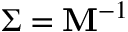<formula> <loc_0><loc_0><loc_500><loc_500>\Sigma = M ^ { - 1 }</formula> 